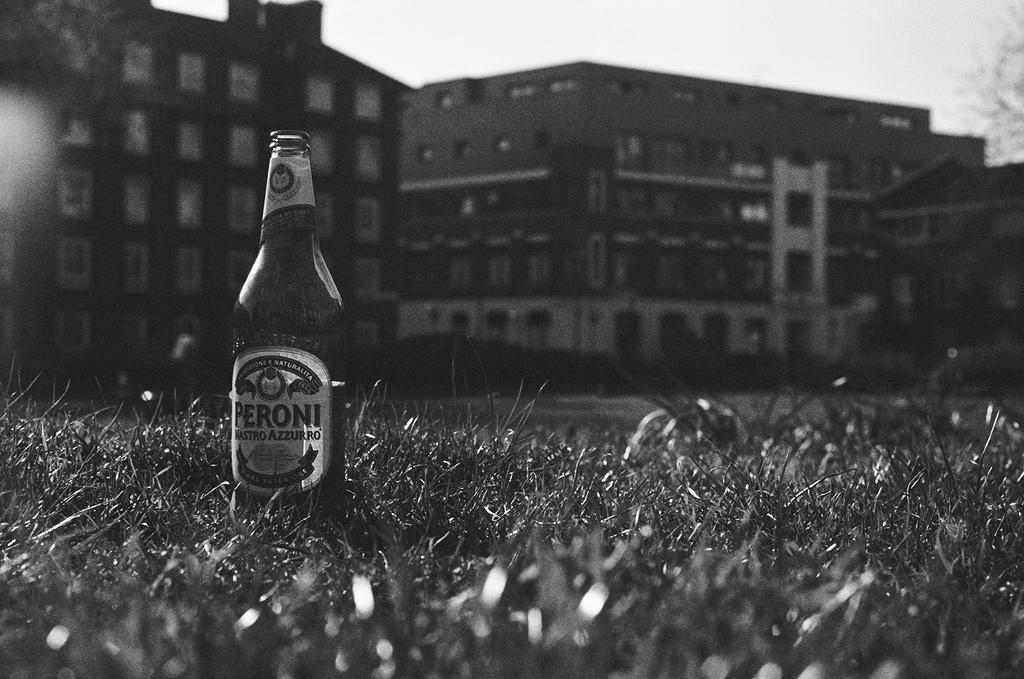Please provide a concise description of this image. In this image on the left there is a bottle. At the bottom there is a grass. In the background there is a building and sky. 